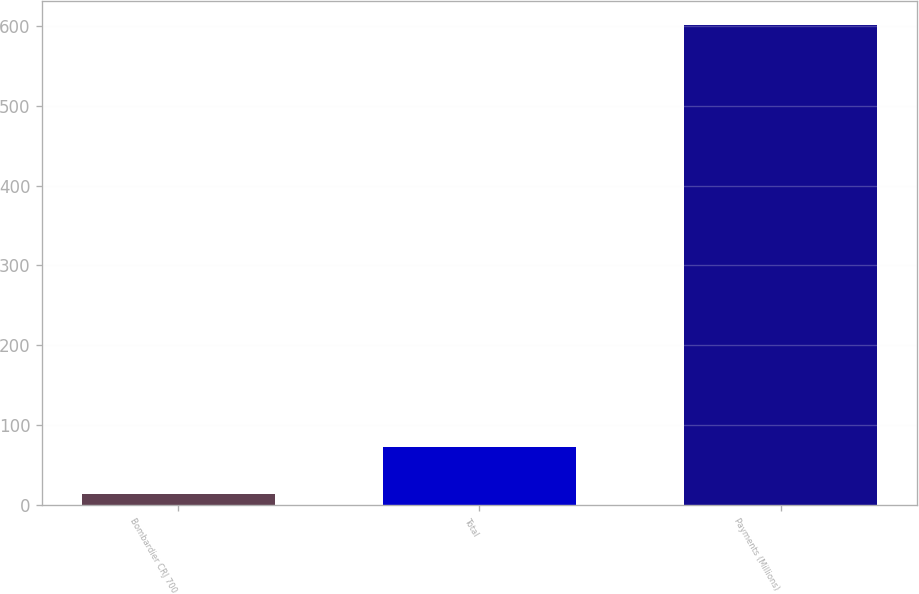Convert chart to OTSL. <chart><loc_0><loc_0><loc_500><loc_500><bar_chart><fcel>Bombardier CRJ 700<fcel>Total<fcel>Payments (Millions)<nl><fcel>14<fcel>72.7<fcel>601<nl></chart> 